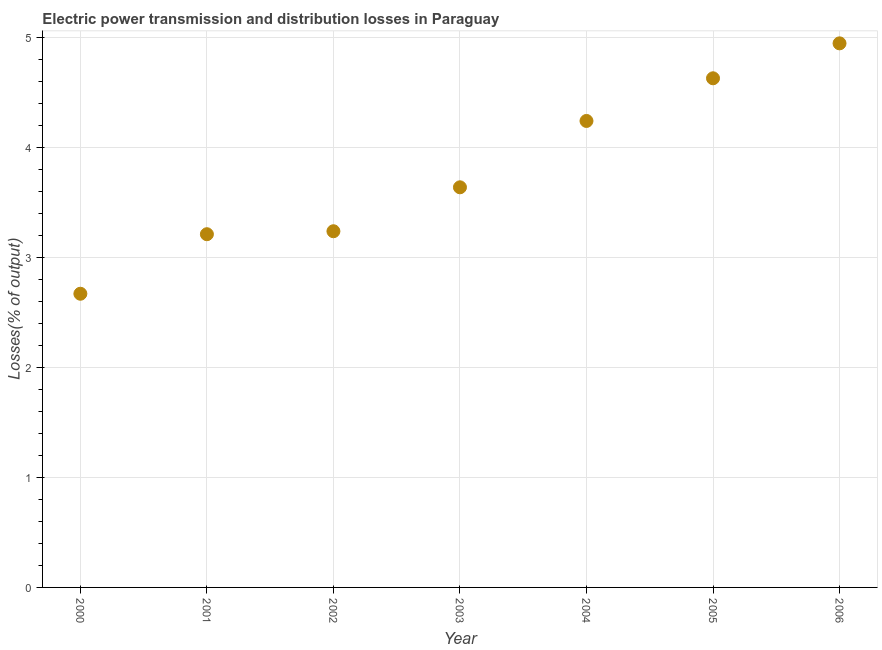What is the electric power transmission and distribution losses in 2006?
Your answer should be compact. 4.95. Across all years, what is the maximum electric power transmission and distribution losses?
Provide a succinct answer. 4.95. Across all years, what is the minimum electric power transmission and distribution losses?
Ensure brevity in your answer.  2.67. What is the sum of the electric power transmission and distribution losses?
Keep it short and to the point. 26.57. What is the difference between the electric power transmission and distribution losses in 2004 and 2005?
Make the answer very short. -0.39. What is the average electric power transmission and distribution losses per year?
Your answer should be compact. 3.8. What is the median electric power transmission and distribution losses?
Keep it short and to the point. 3.64. In how many years, is the electric power transmission and distribution losses greater than 4.6 %?
Provide a short and direct response. 2. What is the ratio of the electric power transmission and distribution losses in 2000 to that in 2005?
Give a very brief answer. 0.58. What is the difference between the highest and the second highest electric power transmission and distribution losses?
Your answer should be compact. 0.32. What is the difference between the highest and the lowest electric power transmission and distribution losses?
Your answer should be compact. 2.28. In how many years, is the electric power transmission and distribution losses greater than the average electric power transmission and distribution losses taken over all years?
Offer a terse response. 3. How many dotlines are there?
Offer a very short reply. 1. Are the values on the major ticks of Y-axis written in scientific E-notation?
Your response must be concise. No. Does the graph contain grids?
Your response must be concise. Yes. What is the title of the graph?
Offer a very short reply. Electric power transmission and distribution losses in Paraguay. What is the label or title of the Y-axis?
Your answer should be very brief. Losses(% of output). What is the Losses(% of output) in 2000?
Keep it short and to the point. 2.67. What is the Losses(% of output) in 2001?
Offer a terse response. 3.21. What is the Losses(% of output) in 2002?
Make the answer very short. 3.24. What is the Losses(% of output) in 2003?
Provide a short and direct response. 3.64. What is the Losses(% of output) in 2004?
Offer a terse response. 4.24. What is the Losses(% of output) in 2005?
Your answer should be very brief. 4.63. What is the Losses(% of output) in 2006?
Offer a very short reply. 4.95. What is the difference between the Losses(% of output) in 2000 and 2001?
Your response must be concise. -0.54. What is the difference between the Losses(% of output) in 2000 and 2002?
Your answer should be very brief. -0.57. What is the difference between the Losses(% of output) in 2000 and 2003?
Keep it short and to the point. -0.97. What is the difference between the Losses(% of output) in 2000 and 2004?
Give a very brief answer. -1.57. What is the difference between the Losses(% of output) in 2000 and 2005?
Provide a succinct answer. -1.96. What is the difference between the Losses(% of output) in 2000 and 2006?
Provide a short and direct response. -2.28. What is the difference between the Losses(% of output) in 2001 and 2002?
Ensure brevity in your answer.  -0.03. What is the difference between the Losses(% of output) in 2001 and 2003?
Provide a succinct answer. -0.43. What is the difference between the Losses(% of output) in 2001 and 2004?
Provide a short and direct response. -1.03. What is the difference between the Losses(% of output) in 2001 and 2005?
Offer a very short reply. -1.42. What is the difference between the Losses(% of output) in 2001 and 2006?
Keep it short and to the point. -1.73. What is the difference between the Losses(% of output) in 2002 and 2003?
Your response must be concise. -0.4. What is the difference between the Losses(% of output) in 2002 and 2004?
Make the answer very short. -1. What is the difference between the Losses(% of output) in 2002 and 2005?
Your answer should be very brief. -1.39. What is the difference between the Losses(% of output) in 2002 and 2006?
Offer a terse response. -1.71. What is the difference between the Losses(% of output) in 2003 and 2004?
Make the answer very short. -0.6. What is the difference between the Losses(% of output) in 2003 and 2005?
Offer a very short reply. -0.99. What is the difference between the Losses(% of output) in 2003 and 2006?
Offer a terse response. -1.31. What is the difference between the Losses(% of output) in 2004 and 2005?
Keep it short and to the point. -0.39. What is the difference between the Losses(% of output) in 2004 and 2006?
Make the answer very short. -0.71. What is the difference between the Losses(% of output) in 2005 and 2006?
Your answer should be very brief. -0.32. What is the ratio of the Losses(% of output) in 2000 to that in 2001?
Offer a very short reply. 0.83. What is the ratio of the Losses(% of output) in 2000 to that in 2002?
Make the answer very short. 0.82. What is the ratio of the Losses(% of output) in 2000 to that in 2003?
Offer a very short reply. 0.73. What is the ratio of the Losses(% of output) in 2000 to that in 2004?
Offer a terse response. 0.63. What is the ratio of the Losses(% of output) in 2000 to that in 2005?
Ensure brevity in your answer.  0.58. What is the ratio of the Losses(% of output) in 2000 to that in 2006?
Offer a terse response. 0.54. What is the ratio of the Losses(% of output) in 2001 to that in 2003?
Provide a short and direct response. 0.88. What is the ratio of the Losses(% of output) in 2001 to that in 2004?
Give a very brief answer. 0.76. What is the ratio of the Losses(% of output) in 2001 to that in 2005?
Offer a very short reply. 0.69. What is the ratio of the Losses(% of output) in 2001 to that in 2006?
Your response must be concise. 0.65. What is the ratio of the Losses(% of output) in 2002 to that in 2003?
Provide a succinct answer. 0.89. What is the ratio of the Losses(% of output) in 2002 to that in 2004?
Keep it short and to the point. 0.76. What is the ratio of the Losses(% of output) in 2002 to that in 2006?
Keep it short and to the point. 0.66. What is the ratio of the Losses(% of output) in 2003 to that in 2004?
Offer a terse response. 0.86. What is the ratio of the Losses(% of output) in 2003 to that in 2005?
Provide a succinct answer. 0.79. What is the ratio of the Losses(% of output) in 2003 to that in 2006?
Make the answer very short. 0.73. What is the ratio of the Losses(% of output) in 2004 to that in 2005?
Your answer should be very brief. 0.92. What is the ratio of the Losses(% of output) in 2004 to that in 2006?
Your response must be concise. 0.86. What is the ratio of the Losses(% of output) in 2005 to that in 2006?
Offer a terse response. 0.94. 